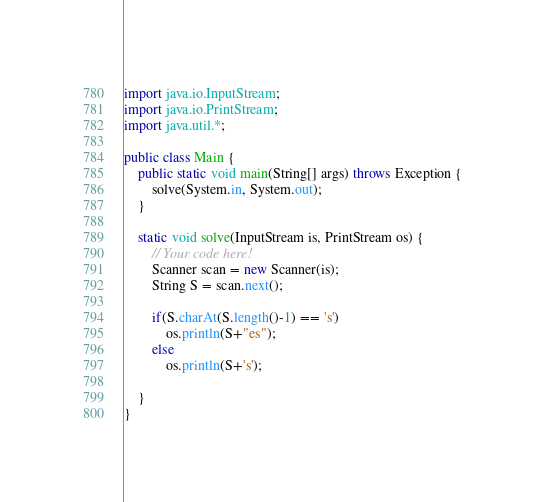Convert code to text. <code><loc_0><loc_0><loc_500><loc_500><_Java_>
import java.io.InputStream;
import java.io.PrintStream;
import java.util.*;

public class Main {
    public static void main(String[] args) throws Exception {
        solve(System.in, System.out);
    }

    static void solve(InputStream is, PrintStream os) {
        // Your code here!
        Scanner scan = new Scanner(is);
        String S = scan.next();

        if(S.charAt(S.length()-1) == 's')
            os.println(S+"es");
        else
            os.println(S+'s');

    }
}</code> 